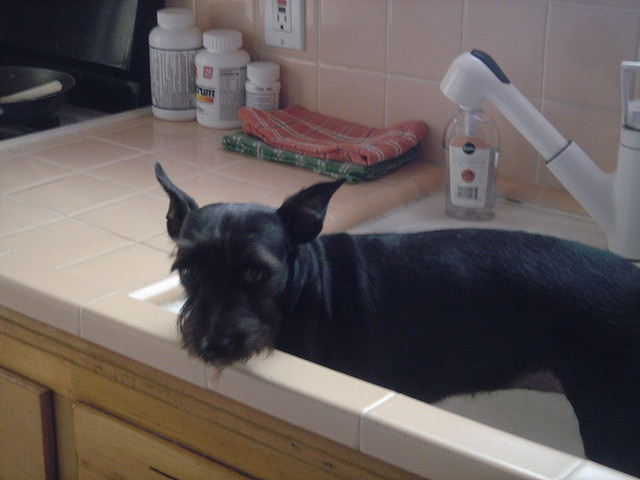Describe the objects in this image and their specific colors. I can see dog in black, gray, and darkblue tones, sink in black and gray tones, oven in black and purple tones, bottle in black and gray tones, and bottle in black and gray tones in this image. 